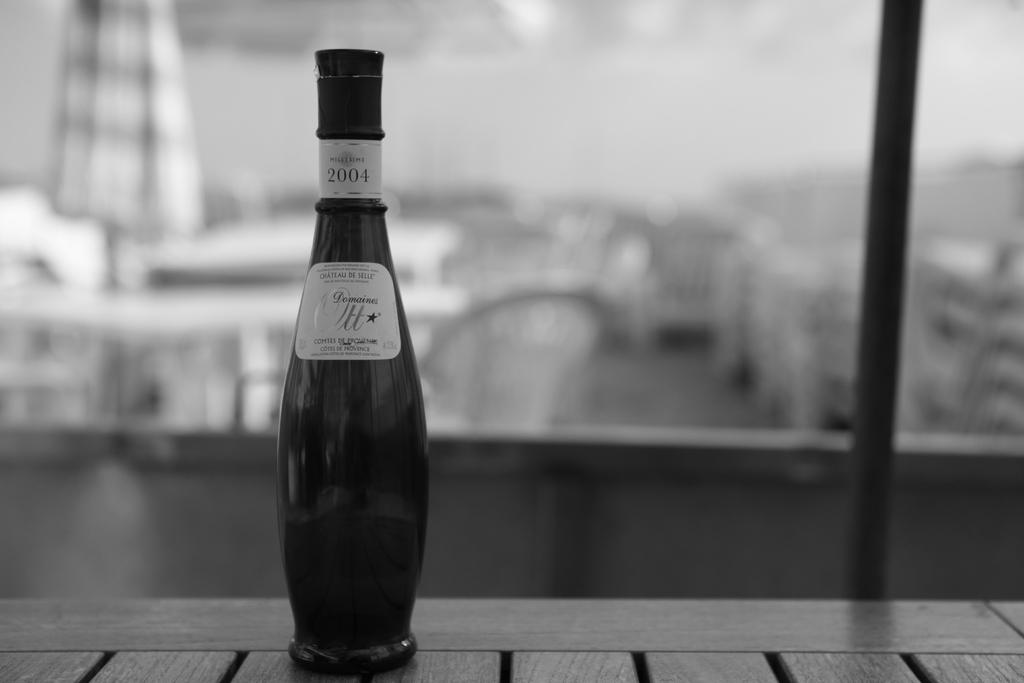Provide a one-sentence caption for the provided image. A tapered liquor bottle bears the Domaines Ott label and a year of 2004.. 